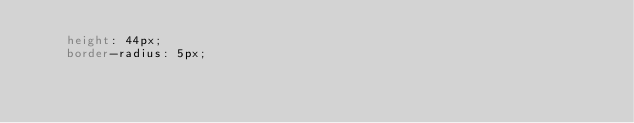<code> <loc_0><loc_0><loc_500><loc_500><_CSS_>    height: 44px;
    border-radius: 5px;</code> 